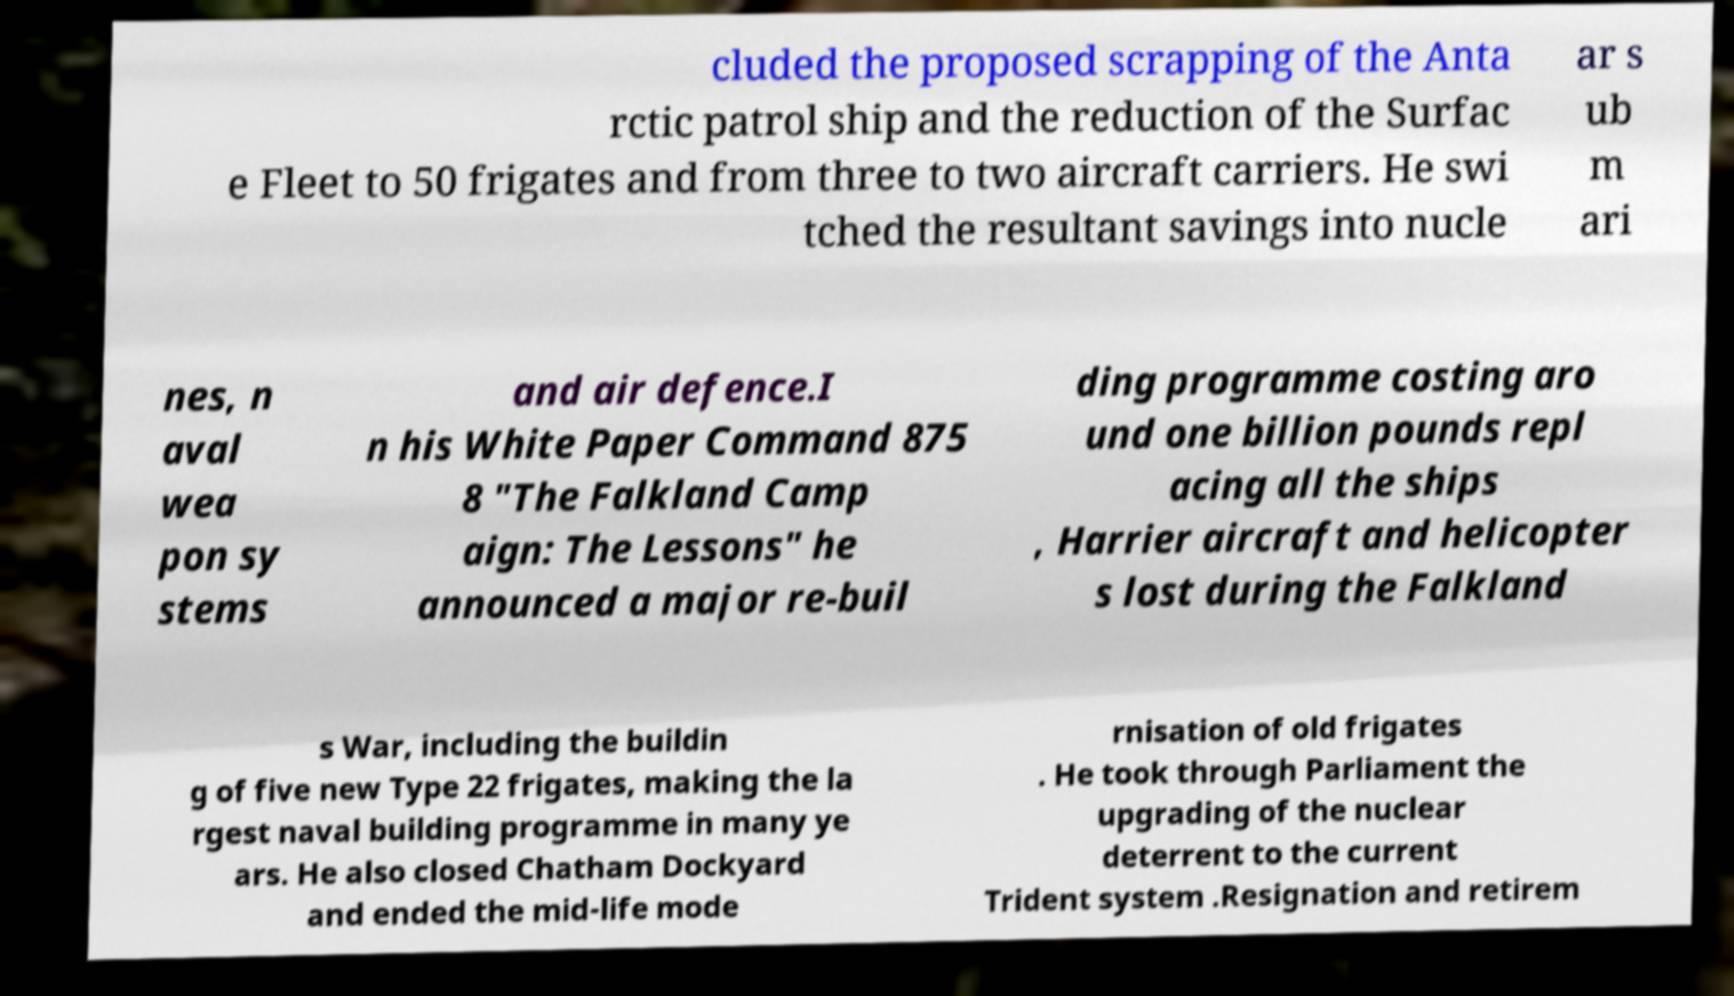Please identify and transcribe the text found in this image. cluded the proposed scrapping of the Anta rctic patrol ship and the reduction of the Surfac e Fleet to 50 frigates and from three to two aircraft carriers. He swi tched the resultant savings into nucle ar s ub m ari nes, n aval wea pon sy stems and air defence.I n his White Paper Command 875 8 "The Falkland Camp aign: The Lessons" he announced a major re-buil ding programme costing aro und one billion pounds repl acing all the ships , Harrier aircraft and helicopter s lost during the Falkland s War, including the buildin g of five new Type 22 frigates, making the la rgest naval building programme in many ye ars. He also closed Chatham Dockyard and ended the mid-life mode rnisation of old frigates . He took through Parliament the upgrading of the nuclear deterrent to the current Trident system .Resignation and retirem 